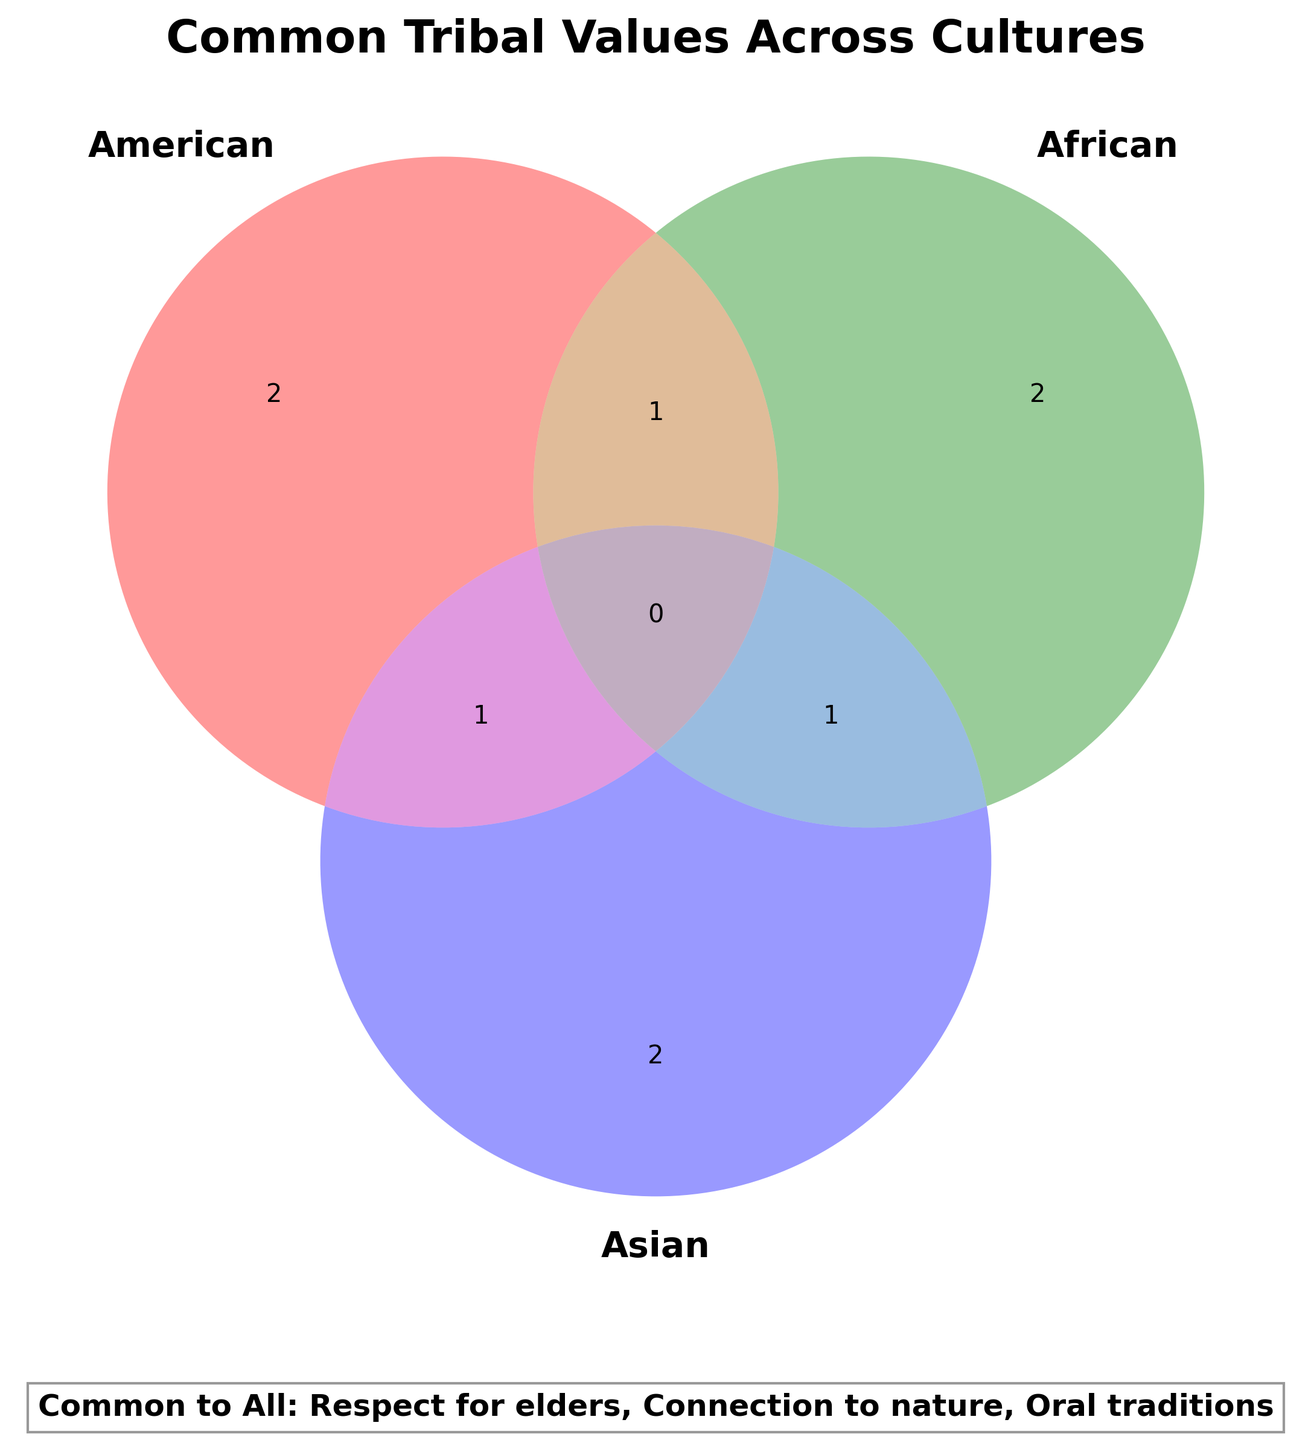What is the title of the Venn Diagram? The title is located at the top of the diagram. It states the main focus of the figure.
Answer: Common Tribal Values Across Cultures Which cultures share communal land ownership? Identify where the label "Communal land ownership" is placed within the Venn Diagram. It is positioned in the overlapping section of the Indigenous American and Indigenous African circles.
Answer: Indigenous American and Indigenous African What is shared among all three cultures? Look at the labels within the overlapping section of all three circles. This identifies the values common to Indigenous American, Indigenous African, and Indigenous Asian cultures.
Answer: None Which culture practices drum ceremonies? Locate the label "Drum ceremonies" within the Venn Diagram. It is positioned inside the circle representing the Indigenous African culture.
Answer: Indigenous African Which common tribal values are shared by Indigenous American and Asian cultures? Identify the overlapping section between the Indigenous American and Indigenous Asian circles. The label "Animistic beliefs" is found here.
Answer: Animistic beliefs Name two values that are unique to a single culture. Look at the segments of the Venn Diagram that do not overlap with any other circle and identify exclusive values. For example, "Sweat lodge rituals" for Indigenous American and "Ancestor worship" for Indigenous Asian.
Answer: Sweat lodge rituals, Ancestor worship What are the common tribal values across all cultures? Reference the text box below the diagram that lists the values common to all cultures mentioned in the figure.
Answer: Respect for elders, Connection to nature, Oral traditions Which cultures share extended family structures? Identify where "Extended family structures" is labeled within the Venn Diagram. It is found in the overlapping area of the Indigenous African and Indigenous Asian circles.
Answer: Indigenous African and Indigenous Asian What additional practice do the Indigenous American and African cultures share besides communal land ownership? Examine the Venn Diagram for the overlapping section of the Indigenous American and Indigenous African circles. Only "Communal land ownership" is shared.
Answer: None Which culture believes in totem animals? Locate the label "Totem animals" within the circles of the Venn Diagram, specifically within Indigenous American.
Answer: Indigenous American 